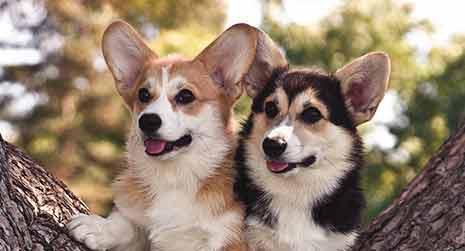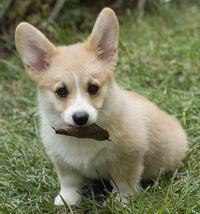The first image is the image on the left, the second image is the image on the right. Considering the images on both sides, is "An image features a multi-colored dog with black markings that create a mask-look." valid? Answer yes or no. Yes. The first image is the image on the left, the second image is the image on the right. Evaluate the accuracy of this statement regarding the images: "At least one dog has some black fur.". Is it true? Answer yes or no. Yes. 